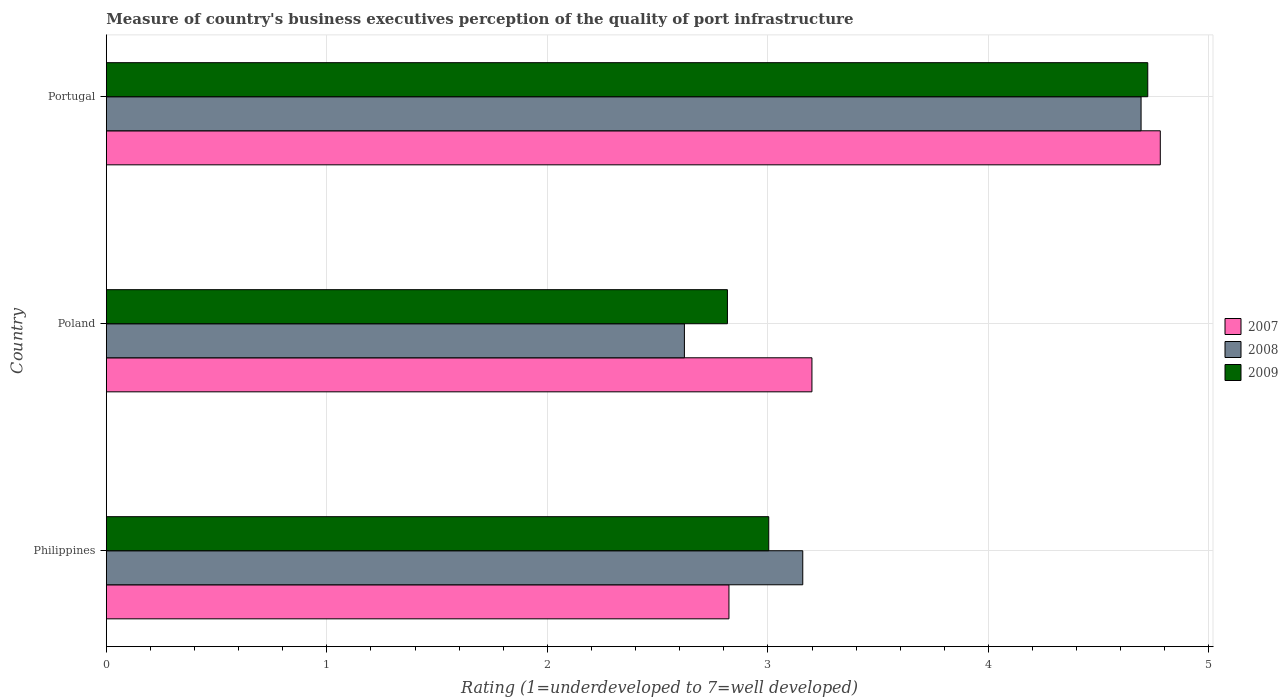Are the number of bars per tick equal to the number of legend labels?
Make the answer very short. Yes. How many bars are there on the 2nd tick from the top?
Your response must be concise. 3. How many bars are there on the 3rd tick from the bottom?
Your response must be concise. 3. What is the ratings of the quality of port infrastructure in 2008 in Poland?
Your response must be concise. 2.62. Across all countries, what is the maximum ratings of the quality of port infrastructure in 2009?
Offer a terse response. 4.72. Across all countries, what is the minimum ratings of the quality of port infrastructure in 2007?
Your answer should be compact. 2.82. In which country was the ratings of the quality of port infrastructure in 2009 maximum?
Provide a short and direct response. Portugal. What is the total ratings of the quality of port infrastructure in 2009 in the graph?
Your answer should be very brief. 10.54. What is the difference between the ratings of the quality of port infrastructure in 2007 in Philippines and that in Poland?
Provide a short and direct response. -0.38. What is the difference between the ratings of the quality of port infrastructure in 2007 in Philippines and the ratings of the quality of port infrastructure in 2008 in Portugal?
Your answer should be very brief. -1.87. What is the average ratings of the quality of port infrastructure in 2009 per country?
Offer a terse response. 3.51. What is the difference between the ratings of the quality of port infrastructure in 2008 and ratings of the quality of port infrastructure in 2007 in Philippines?
Provide a short and direct response. 0.33. In how many countries, is the ratings of the quality of port infrastructure in 2009 greater than 1 ?
Give a very brief answer. 3. What is the ratio of the ratings of the quality of port infrastructure in 2009 in Philippines to that in Portugal?
Offer a very short reply. 0.64. Is the ratings of the quality of port infrastructure in 2009 in Philippines less than that in Portugal?
Ensure brevity in your answer.  Yes. Is the difference between the ratings of the quality of port infrastructure in 2008 in Poland and Portugal greater than the difference between the ratings of the quality of port infrastructure in 2007 in Poland and Portugal?
Provide a short and direct response. No. What is the difference between the highest and the second highest ratings of the quality of port infrastructure in 2009?
Offer a very short reply. 1.72. What is the difference between the highest and the lowest ratings of the quality of port infrastructure in 2009?
Give a very brief answer. 1.91. In how many countries, is the ratings of the quality of port infrastructure in 2009 greater than the average ratings of the quality of port infrastructure in 2009 taken over all countries?
Your answer should be very brief. 1. Is the sum of the ratings of the quality of port infrastructure in 2007 in Poland and Portugal greater than the maximum ratings of the quality of port infrastructure in 2009 across all countries?
Provide a short and direct response. Yes. What does the 3rd bar from the bottom in Poland represents?
Provide a succinct answer. 2009. Is it the case that in every country, the sum of the ratings of the quality of port infrastructure in 2009 and ratings of the quality of port infrastructure in 2007 is greater than the ratings of the quality of port infrastructure in 2008?
Provide a succinct answer. Yes. How many bars are there?
Keep it short and to the point. 9. Are all the bars in the graph horizontal?
Give a very brief answer. Yes. Are the values on the major ticks of X-axis written in scientific E-notation?
Provide a short and direct response. No. Does the graph contain any zero values?
Your response must be concise. No. How many legend labels are there?
Keep it short and to the point. 3. What is the title of the graph?
Your response must be concise. Measure of country's business executives perception of the quality of port infrastructure. Does "1988" appear as one of the legend labels in the graph?
Offer a terse response. No. What is the label or title of the X-axis?
Your answer should be very brief. Rating (1=underdeveloped to 7=well developed). What is the label or title of the Y-axis?
Offer a very short reply. Country. What is the Rating (1=underdeveloped to 7=well developed) in 2007 in Philippines?
Your answer should be compact. 2.82. What is the Rating (1=underdeveloped to 7=well developed) of 2008 in Philippines?
Offer a very short reply. 3.16. What is the Rating (1=underdeveloped to 7=well developed) of 2009 in Philippines?
Your answer should be compact. 3. What is the Rating (1=underdeveloped to 7=well developed) in 2007 in Poland?
Your answer should be very brief. 3.2. What is the Rating (1=underdeveloped to 7=well developed) of 2008 in Poland?
Ensure brevity in your answer.  2.62. What is the Rating (1=underdeveloped to 7=well developed) in 2009 in Poland?
Offer a very short reply. 2.82. What is the Rating (1=underdeveloped to 7=well developed) in 2007 in Portugal?
Keep it short and to the point. 4.78. What is the Rating (1=underdeveloped to 7=well developed) in 2008 in Portugal?
Your response must be concise. 4.69. What is the Rating (1=underdeveloped to 7=well developed) of 2009 in Portugal?
Provide a short and direct response. 4.72. Across all countries, what is the maximum Rating (1=underdeveloped to 7=well developed) of 2007?
Offer a very short reply. 4.78. Across all countries, what is the maximum Rating (1=underdeveloped to 7=well developed) in 2008?
Your answer should be compact. 4.69. Across all countries, what is the maximum Rating (1=underdeveloped to 7=well developed) of 2009?
Make the answer very short. 4.72. Across all countries, what is the minimum Rating (1=underdeveloped to 7=well developed) in 2007?
Offer a very short reply. 2.82. Across all countries, what is the minimum Rating (1=underdeveloped to 7=well developed) in 2008?
Provide a short and direct response. 2.62. Across all countries, what is the minimum Rating (1=underdeveloped to 7=well developed) of 2009?
Give a very brief answer. 2.82. What is the total Rating (1=underdeveloped to 7=well developed) in 2007 in the graph?
Your response must be concise. 10.8. What is the total Rating (1=underdeveloped to 7=well developed) in 2008 in the graph?
Your response must be concise. 10.47. What is the total Rating (1=underdeveloped to 7=well developed) in 2009 in the graph?
Offer a very short reply. 10.54. What is the difference between the Rating (1=underdeveloped to 7=well developed) in 2007 in Philippines and that in Poland?
Provide a succinct answer. -0.38. What is the difference between the Rating (1=underdeveloped to 7=well developed) in 2008 in Philippines and that in Poland?
Your answer should be compact. 0.54. What is the difference between the Rating (1=underdeveloped to 7=well developed) in 2009 in Philippines and that in Poland?
Keep it short and to the point. 0.19. What is the difference between the Rating (1=underdeveloped to 7=well developed) of 2007 in Philippines and that in Portugal?
Your response must be concise. -1.96. What is the difference between the Rating (1=underdeveloped to 7=well developed) of 2008 in Philippines and that in Portugal?
Provide a succinct answer. -1.53. What is the difference between the Rating (1=underdeveloped to 7=well developed) in 2009 in Philippines and that in Portugal?
Provide a succinct answer. -1.72. What is the difference between the Rating (1=underdeveloped to 7=well developed) in 2007 in Poland and that in Portugal?
Provide a short and direct response. -1.58. What is the difference between the Rating (1=underdeveloped to 7=well developed) of 2008 in Poland and that in Portugal?
Provide a short and direct response. -2.07. What is the difference between the Rating (1=underdeveloped to 7=well developed) in 2009 in Poland and that in Portugal?
Your answer should be very brief. -1.91. What is the difference between the Rating (1=underdeveloped to 7=well developed) in 2007 in Philippines and the Rating (1=underdeveloped to 7=well developed) in 2008 in Poland?
Your answer should be very brief. 0.2. What is the difference between the Rating (1=underdeveloped to 7=well developed) of 2007 in Philippines and the Rating (1=underdeveloped to 7=well developed) of 2009 in Poland?
Give a very brief answer. 0.01. What is the difference between the Rating (1=underdeveloped to 7=well developed) in 2008 in Philippines and the Rating (1=underdeveloped to 7=well developed) in 2009 in Poland?
Offer a very short reply. 0.34. What is the difference between the Rating (1=underdeveloped to 7=well developed) in 2007 in Philippines and the Rating (1=underdeveloped to 7=well developed) in 2008 in Portugal?
Offer a terse response. -1.87. What is the difference between the Rating (1=underdeveloped to 7=well developed) in 2007 in Philippines and the Rating (1=underdeveloped to 7=well developed) in 2009 in Portugal?
Ensure brevity in your answer.  -1.9. What is the difference between the Rating (1=underdeveloped to 7=well developed) of 2008 in Philippines and the Rating (1=underdeveloped to 7=well developed) of 2009 in Portugal?
Offer a terse response. -1.56. What is the difference between the Rating (1=underdeveloped to 7=well developed) of 2007 in Poland and the Rating (1=underdeveloped to 7=well developed) of 2008 in Portugal?
Offer a terse response. -1.49. What is the difference between the Rating (1=underdeveloped to 7=well developed) in 2007 in Poland and the Rating (1=underdeveloped to 7=well developed) in 2009 in Portugal?
Offer a very short reply. -1.52. What is the difference between the Rating (1=underdeveloped to 7=well developed) of 2008 in Poland and the Rating (1=underdeveloped to 7=well developed) of 2009 in Portugal?
Your answer should be very brief. -2.1. What is the average Rating (1=underdeveloped to 7=well developed) in 2007 per country?
Your answer should be compact. 3.6. What is the average Rating (1=underdeveloped to 7=well developed) in 2008 per country?
Keep it short and to the point. 3.49. What is the average Rating (1=underdeveloped to 7=well developed) of 2009 per country?
Keep it short and to the point. 3.51. What is the difference between the Rating (1=underdeveloped to 7=well developed) in 2007 and Rating (1=underdeveloped to 7=well developed) in 2008 in Philippines?
Keep it short and to the point. -0.33. What is the difference between the Rating (1=underdeveloped to 7=well developed) of 2007 and Rating (1=underdeveloped to 7=well developed) of 2009 in Philippines?
Ensure brevity in your answer.  -0.18. What is the difference between the Rating (1=underdeveloped to 7=well developed) in 2008 and Rating (1=underdeveloped to 7=well developed) in 2009 in Philippines?
Make the answer very short. 0.15. What is the difference between the Rating (1=underdeveloped to 7=well developed) in 2007 and Rating (1=underdeveloped to 7=well developed) in 2008 in Poland?
Ensure brevity in your answer.  0.58. What is the difference between the Rating (1=underdeveloped to 7=well developed) of 2007 and Rating (1=underdeveloped to 7=well developed) of 2009 in Poland?
Provide a succinct answer. 0.38. What is the difference between the Rating (1=underdeveloped to 7=well developed) in 2008 and Rating (1=underdeveloped to 7=well developed) in 2009 in Poland?
Provide a short and direct response. -0.2. What is the difference between the Rating (1=underdeveloped to 7=well developed) in 2007 and Rating (1=underdeveloped to 7=well developed) in 2008 in Portugal?
Your answer should be compact. 0.09. What is the difference between the Rating (1=underdeveloped to 7=well developed) in 2007 and Rating (1=underdeveloped to 7=well developed) in 2009 in Portugal?
Your answer should be very brief. 0.06. What is the difference between the Rating (1=underdeveloped to 7=well developed) of 2008 and Rating (1=underdeveloped to 7=well developed) of 2009 in Portugal?
Your answer should be very brief. -0.03. What is the ratio of the Rating (1=underdeveloped to 7=well developed) of 2007 in Philippines to that in Poland?
Your answer should be compact. 0.88. What is the ratio of the Rating (1=underdeveloped to 7=well developed) of 2008 in Philippines to that in Poland?
Provide a succinct answer. 1.2. What is the ratio of the Rating (1=underdeveloped to 7=well developed) of 2009 in Philippines to that in Poland?
Ensure brevity in your answer.  1.07. What is the ratio of the Rating (1=underdeveloped to 7=well developed) of 2007 in Philippines to that in Portugal?
Offer a terse response. 0.59. What is the ratio of the Rating (1=underdeveloped to 7=well developed) of 2008 in Philippines to that in Portugal?
Keep it short and to the point. 0.67. What is the ratio of the Rating (1=underdeveloped to 7=well developed) of 2009 in Philippines to that in Portugal?
Provide a succinct answer. 0.64. What is the ratio of the Rating (1=underdeveloped to 7=well developed) in 2007 in Poland to that in Portugal?
Offer a very short reply. 0.67. What is the ratio of the Rating (1=underdeveloped to 7=well developed) of 2008 in Poland to that in Portugal?
Ensure brevity in your answer.  0.56. What is the ratio of the Rating (1=underdeveloped to 7=well developed) of 2009 in Poland to that in Portugal?
Make the answer very short. 0.6. What is the difference between the highest and the second highest Rating (1=underdeveloped to 7=well developed) of 2007?
Your answer should be very brief. 1.58. What is the difference between the highest and the second highest Rating (1=underdeveloped to 7=well developed) of 2008?
Offer a terse response. 1.53. What is the difference between the highest and the second highest Rating (1=underdeveloped to 7=well developed) of 2009?
Your answer should be very brief. 1.72. What is the difference between the highest and the lowest Rating (1=underdeveloped to 7=well developed) of 2007?
Offer a very short reply. 1.96. What is the difference between the highest and the lowest Rating (1=underdeveloped to 7=well developed) of 2008?
Offer a terse response. 2.07. What is the difference between the highest and the lowest Rating (1=underdeveloped to 7=well developed) in 2009?
Provide a short and direct response. 1.91. 